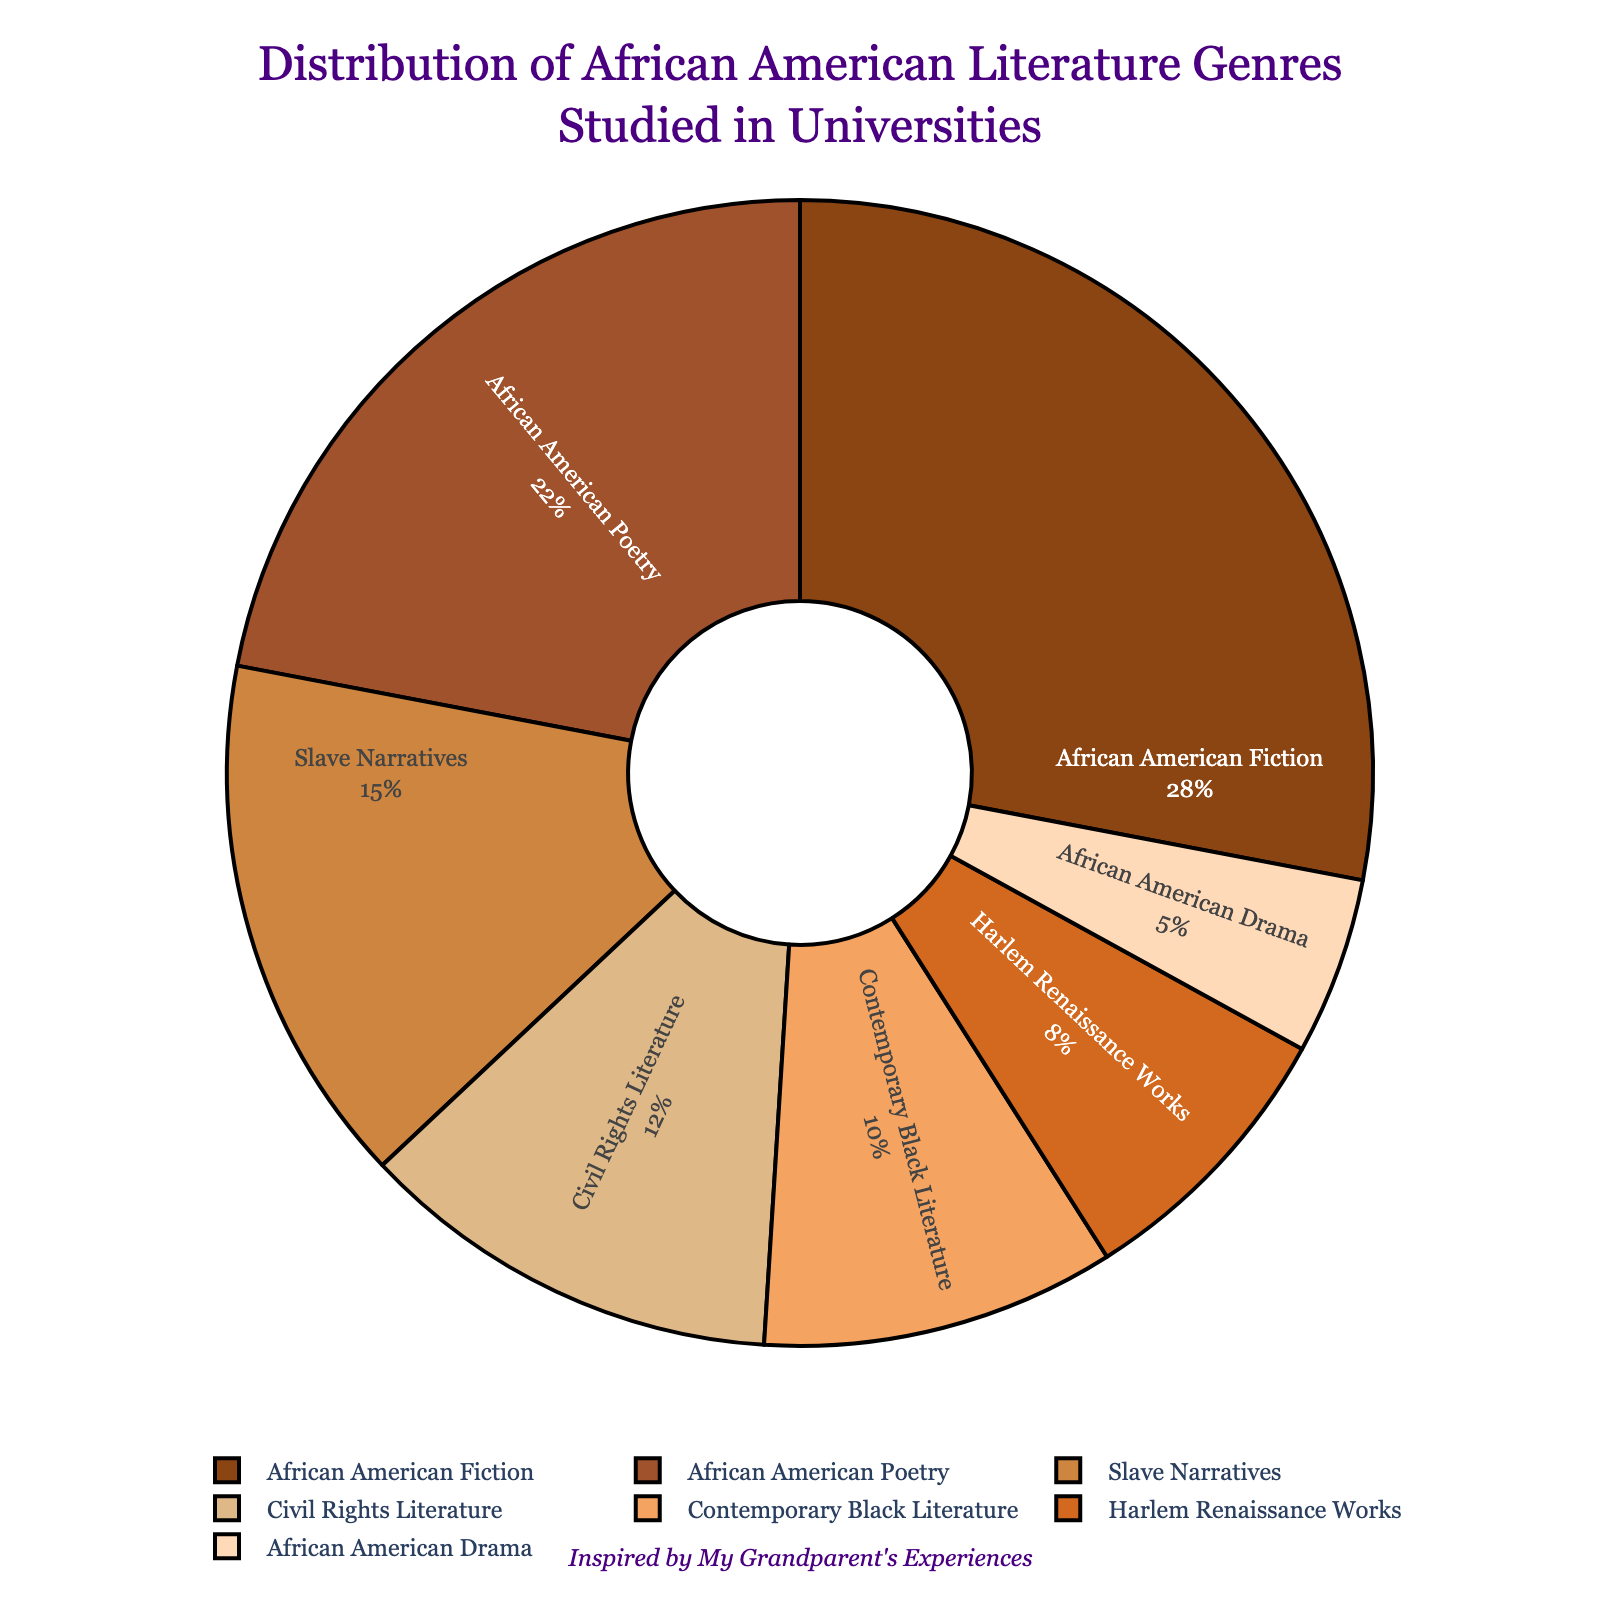What genre has the highest percentage in the distribution? The pie chart shows the percentage distribution of various African American literature genres. The genre with the highest percentage is African American Fiction at 28%.
Answer: African American Fiction Which genre has the lowest percentage, and what is that percentage? By observing the pie chart, the genre with the lowest percentage is African American Drama, which has a percentage of 5%.
Answer: African American Drama, 5% How much larger is the percentage of African American Fiction compared to Harlem Renaissance Works? The percentage of African American Fiction is 28%, and the Harlem Renaissance Works' percentage is 8%. The difference is 28% - 8% = 20%.
Answer: 20% What is the combined percentage of Slave Narratives, Civil Rights Literature, and Contemporary Black Literature? To find the combined percentage, add the percentages of all three genres: 15% (Slave Narratives) + 12% (Civil Rights Literature) + 10% (Contemporary Black Literature) = 37%.
Answer: 37% Is the percentage of African American Poetry greater than Civil Rights Literature? If so, by how much? African American Poetry is 22%, and Civil Rights Literature is 12%. The difference is 22% - 12% = 10%.
Answer: Yes, by 10% Which genre has a percentage closest to 10%? By looking at the chart, Contemporary Black Literature has a percentage of exactly 10%, which is the closest to 10%.
Answer: Contemporary Black Literature How does the combined percentage of African American Fiction and African American Poetry compare to half of the total percentage? The combined percentage of African American Fiction (28%) and African American Poetry (22%) is 28% + 22% = 50%. Half of the total percentage is 50%, so they are equal.
Answer: They are equal What is the average percentage of African American Drama, Harlem Renaissance Works, and Civil Rights Literature? Add the percentages first: 5% (African American Drama) + 8% (Harlem Renaissance Works) + 12% (Civil Rights Literature) = 25%. Then divide by 3: 25% / 3 ≈ 8.33%.
Answer: ≈ 8.33% How much larger is the total percentage of Fiction and Poetry than the total for Slave Narratives and Civil Rights Literature? First, find the total for Fiction and Poetry: 28% (Fiction) + 22% (Poetry) = 50%. Then, find the total for Slave Narratives and Civil Rights Literature: 15% + 12% = 27%. The difference is 50% - 27% = 23%.
Answer: 23% Which genres comprise less than 10% of the distribution? From the chart, the genres with less than 10% are Harlem Renaissance Works (8%) and African American Drama (5%).
Answer: Harlem Renaissance Works and African American Drama 